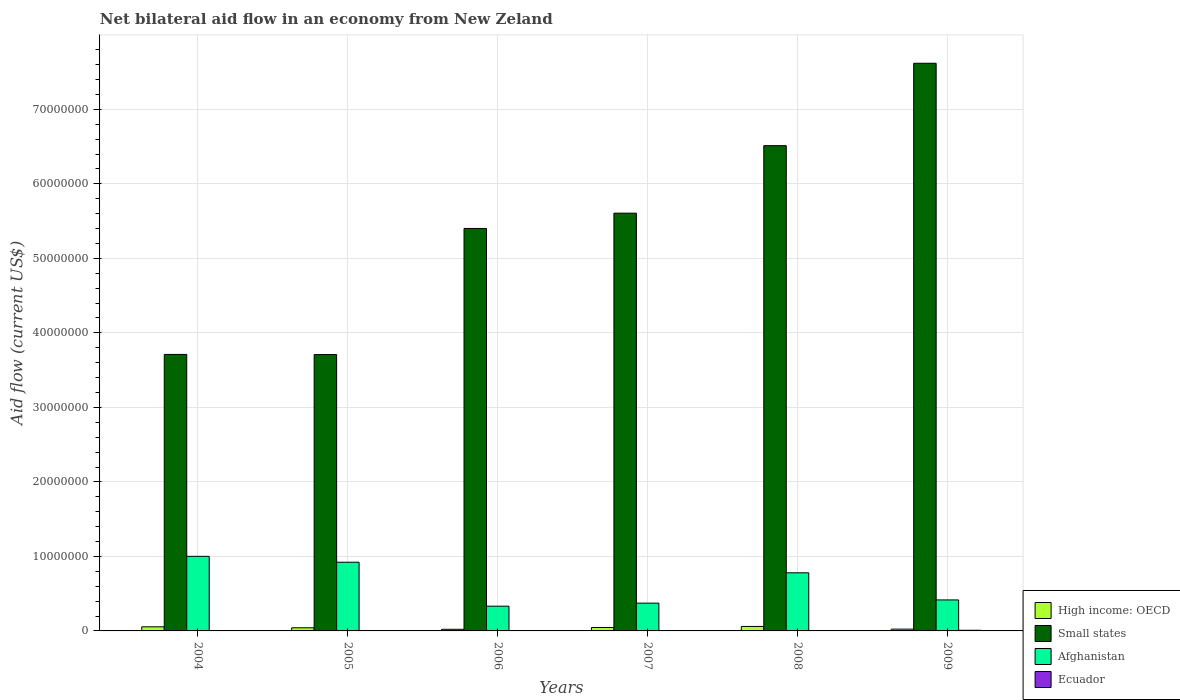How many different coloured bars are there?
Your response must be concise. 4. Are the number of bars per tick equal to the number of legend labels?
Provide a succinct answer. Yes. In how many cases, is the number of bars for a given year not equal to the number of legend labels?
Make the answer very short. 0. What is the net bilateral aid flow in Small states in 2005?
Give a very brief answer. 3.71e+07. Across all years, what is the maximum net bilateral aid flow in Ecuador?
Provide a short and direct response. 9.00e+04. In which year was the net bilateral aid flow in Afghanistan maximum?
Provide a succinct answer. 2004. What is the difference between the net bilateral aid flow in Afghanistan in 2006 and that in 2007?
Offer a very short reply. -4.10e+05. What is the average net bilateral aid flow in Ecuador per year?
Your answer should be very brief. 4.17e+04. In the year 2006, what is the difference between the net bilateral aid flow in High income: OECD and net bilateral aid flow in Small states?
Offer a terse response. -5.38e+07. What is the ratio of the net bilateral aid flow in Afghanistan in 2005 to that in 2007?
Your answer should be compact. 2.47. What is the difference between the highest and the lowest net bilateral aid flow in Afghanistan?
Your response must be concise. 6.69e+06. In how many years, is the net bilateral aid flow in Small states greater than the average net bilateral aid flow in Small states taken over all years?
Offer a terse response. 3. Is the sum of the net bilateral aid flow in Small states in 2006 and 2008 greater than the maximum net bilateral aid flow in High income: OECD across all years?
Provide a short and direct response. Yes. What does the 3rd bar from the left in 2008 represents?
Keep it short and to the point. Afghanistan. What does the 3rd bar from the right in 2008 represents?
Give a very brief answer. Small states. How many years are there in the graph?
Keep it short and to the point. 6. What is the difference between two consecutive major ticks on the Y-axis?
Your answer should be very brief. 1.00e+07. Does the graph contain any zero values?
Make the answer very short. No. Does the graph contain grids?
Give a very brief answer. Yes. How many legend labels are there?
Give a very brief answer. 4. How are the legend labels stacked?
Offer a terse response. Vertical. What is the title of the graph?
Offer a very short reply. Net bilateral aid flow in an economy from New Zeland. What is the label or title of the X-axis?
Provide a succinct answer. Years. What is the label or title of the Y-axis?
Ensure brevity in your answer.  Aid flow (current US$). What is the Aid flow (current US$) in Small states in 2004?
Your response must be concise. 3.71e+07. What is the Aid flow (current US$) in Afghanistan in 2004?
Give a very brief answer. 1.00e+07. What is the Aid flow (current US$) in Small states in 2005?
Offer a terse response. 3.71e+07. What is the Aid flow (current US$) in Afghanistan in 2005?
Your answer should be compact. 9.22e+06. What is the Aid flow (current US$) in Small states in 2006?
Give a very brief answer. 5.40e+07. What is the Aid flow (current US$) of Afghanistan in 2006?
Provide a short and direct response. 3.32e+06. What is the Aid flow (current US$) of High income: OECD in 2007?
Provide a short and direct response. 4.60e+05. What is the Aid flow (current US$) in Small states in 2007?
Offer a terse response. 5.61e+07. What is the Aid flow (current US$) in Afghanistan in 2007?
Provide a succinct answer. 3.73e+06. What is the Aid flow (current US$) in Ecuador in 2007?
Give a very brief answer. 2.00e+04. What is the Aid flow (current US$) in Small states in 2008?
Ensure brevity in your answer.  6.51e+07. What is the Aid flow (current US$) in Afghanistan in 2008?
Give a very brief answer. 7.80e+06. What is the Aid flow (current US$) of High income: OECD in 2009?
Give a very brief answer. 2.40e+05. What is the Aid flow (current US$) of Small states in 2009?
Ensure brevity in your answer.  7.62e+07. What is the Aid flow (current US$) of Afghanistan in 2009?
Your response must be concise. 4.16e+06. What is the Aid flow (current US$) of Ecuador in 2009?
Your answer should be compact. 9.00e+04. Across all years, what is the maximum Aid flow (current US$) of High income: OECD?
Make the answer very short. 6.00e+05. Across all years, what is the maximum Aid flow (current US$) of Small states?
Offer a very short reply. 7.62e+07. Across all years, what is the maximum Aid flow (current US$) in Afghanistan?
Ensure brevity in your answer.  1.00e+07. Across all years, what is the minimum Aid flow (current US$) in High income: OECD?
Provide a succinct answer. 2.20e+05. Across all years, what is the minimum Aid flow (current US$) in Small states?
Offer a very short reply. 3.71e+07. Across all years, what is the minimum Aid flow (current US$) in Afghanistan?
Ensure brevity in your answer.  3.32e+06. What is the total Aid flow (current US$) in High income: OECD in the graph?
Make the answer very short. 2.49e+06. What is the total Aid flow (current US$) in Small states in the graph?
Your answer should be very brief. 3.26e+08. What is the total Aid flow (current US$) of Afghanistan in the graph?
Keep it short and to the point. 3.82e+07. What is the total Aid flow (current US$) in Ecuador in the graph?
Offer a very short reply. 2.50e+05. What is the difference between the Aid flow (current US$) in High income: OECD in 2004 and that in 2005?
Make the answer very short. 1.30e+05. What is the difference between the Aid flow (current US$) of Small states in 2004 and that in 2005?
Offer a terse response. 2.00e+04. What is the difference between the Aid flow (current US$) of Afghanistan in 2004 and that in 2005?
Provide a succinct answer. 7.90e+05. What is the difference between the Aid flow (current US$) in Small states in 2004 and that in 2006?
Your response must be concise. -1.69e+07. What is the difference between the Aid flow (current US$) of Afghanistan in 2004 and that in 2006?
Keep it short and to the point. 6.69e+06. What is the difference between the Aid flow (current US$) of High income: OECD in 2004 and that in 2007?
Your response must be concise. 9.00e+04. What is the difference between the Aid flow (current US$) in Small states in 2004 and that in 2007?
Ensure brevity in your answer.  -1.90e+07. What is the difference between the Aid flow (current US$) in Afghanistan in 2004 and that in 2007?
Your answer should be compact. 6.28e+06. What is the difference between the Aid flow (current US$) in High income: OECD in 2004 and that in 2008?
Offer a terse response. -5.00e+04. What is the difference between the Aid flow (current US$) of Small states in 2004 and that in 2008?
Ensure brevity in your answer.  -2.80e+07. What is the difference between the Aid flow (current US$) in Afghanistan in 2004 and that in 2008?
Make the answer very short. 2.21e+06. What is the difference between the Aid flow (current US$) of Ecuador in 2004 and that in 2008?
Offer a terse response. -10000. What is the difference between the Aid flow (current US$) of High income: OECD in 2004 and that in 2009?
Your answer should be very brief. 3.10e+05. What is the difference between the Aid flow (current US$) of Small states in 2004 and that in 2009?
Offer a terse response. -3.91e+07. What is the difference between the Aid flow (current US$) in Afghanistan in 2004 and that in 2009?
Provide a short and direct response. 5.85e+06. What is the difference between the Aid flow (current US$) of High income: OECD in 2005 and that in 2006?
Make the answer very short. 2.00e+05. What is the difference between the Aid flow (current US$) of Small states in 2005 and that in 2006?
Keep it short and to the point. -1.69e+07. What is the difference between the Aid flow (current US$) in Afghanistan in 2005 and that in 2006?
Your answer should be very brief. 5.90e+06. What is the difference between the Aid flow (current US$) of Ecuador in 2005 and that in 2006?
Provide a succinct answer. -10000. What is the difference between the Aid flow (current US$) in High income: OECD in 2005 and that in 2007?
Your response must be concise. -4.00e+04. What is the difference between the Aid flow (current US$) in Small states in 2005 and that in 2007?
Ensure brevity in your answer.  -1.90e+07. What is the difference between the Aid flow (current US$) in Afghanistan in 2005 and that in 2007?
Offer a very short reply. 5.49e+06. What is the difference between the Aid flow (current US$) of Ecuador in 2005 and that in 2007?
Offer a terse response. 10000. What is the difference between the Aid flow (current US$) in Small states in 2005 and that in 2008?
Your response must be concise. -2.80e+07. What is the difference between the Aid flow (current US$) of Afghanistan in 2005 and that in 2008?
Provide a short and direct response. 1.42e+06. What is the difference between the Aid flow (current US$) of Ecuador in 2005 and that in 2008?
Provide a succinct answer. -10000. What is the difference between the Aid flow (current US$) in High income: OECD in 2005 and that in 2009?
Your response must be concise. 1.80e+05. What is the difference between the Aid flow (current US$) of Small states in 2005 and that in 2009?
Keep it short and to the point. -3.91e+07. What is the difference between the Aid flow (current US$) of Afghanistan in 2005 and that in 2009?
Ensure brevity in your answer.  5.06e+06. What is the difference between the Aid flow (current US$) in Small states in 2006 and that in 2007?
Make the answer very short. -2.05e+06. What is the difference between the Aid flow (current US$) in Afghanistan in 2006 and that in 2007?
Provide a short and direct response. -4.10e+05. What is the difference between the Aid flow (current US$) of High income: OECD in 2006 and that in 2008?
Give a very brief answer. -3.80e+05. What is the difference between the Aid flow (current US$) of Small states in 2006 and that in 2008?
Ensure brevity in your answer.  -1.11e+07. What is the difference between the Aid flow (current US$) of Afghanistan in 2006 and that in 2008?
Keep it short and to the point. -4.48e+06. What is the difference between the Aid flow (current US$) of Small states in 2006 and that in 2009?
Ensure brevity in your answer.  -2.22e+07. What is the difference between the Aid flow (current US$) in Afghanistan in 2006 and that in 2009?
Your response must be concise. -8.40e+05. What is the difference between the Aid flow (current US$) of Ecuador in 2006 and that in 2009?
Offer a very short reply. -5.00e+04. What is the difference between the Aid flow (current US$) in High income: OECD in 2007 and that in 2008?
Provide a succinct answer. -1.40e+05. What is the difference between the Aid flow (current US$) of Small states in 2007 and that in 2008?
Make the answer very short. -9.06e+06. What is the difference between the Aid flow (current US$) in Afghanistan in 2007 and that in 2008?
Offer a very short reply. -4.07e+06. What is the difference between the Aid flow (current US$) of Ecuador in 2007 and that in 2008?
Provide a short and direct response. -2.00e+04. What is the difference between the Aid flow (current US$) of Small states in 2007 and that in 2009?
Give a very brief answer. -2.01e+07. What is the difference between the Aid flow (current US$) in Afghanistan in 2007 and that in 2009?
Your response must be concise. -4.30e+05. What is the difference between the Aid flow (current US$) in Ecuador in 2007 and that in 2009?
Ensure brevity in your answer.  -7.00e+04. What is the difference between the Aid flow (current US$) in High income: OECD in 2008 and that in 2009?
Offer a very short reply. 3.60e+05. What is the difference between the Aid flow (current US$) of Small states in 2008 and that in 2009?
Your response must be concise. -1.11e+07. What is the difference between the Aid flow (current US$) in Afghanistan in 2008 and that in 2009?
Your answer should be compact. 3.64e+06. What is the difference between the Aid flow (current US$) in High income: OECD in 2004 and the Aid flow (current US$) in Small states in 2005?
Your response must be concise. -3.65e+07. What is the difference between the Aid flow (current US$) of High income: OECD in 2004 and the Aid flow (current US$) of Afghanistan in 2005?
Offer a very short reply. -8.67e+06. What is the difference between the Aid flow (current US$) of High income: OECD in 2004 and the Aid flow (current US$) of Ecuador in 2005?
Offer a terse response. 5.20e+05. What is the difference between the Aid flow (current US$) of Small states in 2004 and the Aid flow (current US$) of Afghanistan in 2005?
Offer a very short reply. 2.79e+07. What is the difference between the Aid flow (current US$) of Small states in 2004 and the Aid flow (current US$) of Ecuador in 2005?
Ensure brevity in your answer.  3.71e+07. What is the difference between the Aid flow (current US$) in Afghanistan in 2004 and the Aid flow (current US$) in Ecuador in 2005?
Your answer should be compact. 9.98e+06. What is the difference between the Aid flow (current US$) in High income: OECD in 2004 and the Aid flow (current US$) in Small states in 2006?
Keep it short and to the point. -5.35e+07. What is the difference between the Aid flow (current US$) of High income: OECD in 2004 and the Aid flow (current US$) of Afghanistan in 2006?
Your answer should be compact. -2.77e+06. What is the difference between the Aid flow (current US$) in High income: OECD in 2004 and the Aid flow (current US$) in Ecuador in 2006?
Make the answer very short. 5.10e+05. What is the difference between the Aid flow (current US$) of Small states in 2004 and the Aid flow (current US$) of Afghanistan in 2006?
Keep it short and to the point. 3.38e+07. What is the difference between the Aid flow (current US$) of Small states in 2004 and the Aid flow (current US$) of Ecuador in 2006?
Give a very brief answer. 3.71e+07. What is the difference between the Aid flow (current US$) of Afghanistan in 2004 and the Aid flow (current US$) of Ecuador in 2006?
Offer a very short reply. 9.97e+06. What is the difference between the Aid flow (current US$) of High income: OECD in 2004 and the Aid flow (current US$) of Small states in 2007?
Your response must be concise. -5.55e+07. What is the difference between the Aid flow (current US$) in High income: OECD in 2004 and the Aid flow (current US$) in Afghanistan in 2007?
Offer a very short reply. -3.18e+06. What is the difference between the Aid flow (current US$) in High income: OECD in 2004 and the Aid flow (current US$) in Ecuador in 2007?
Ensure brevity in your answer.  5.30e+05. What is the difference between the Aid flow (current US$) in Small states in 2004 and the Aid flow (current US$) in Afghanistan in 2007?
Your response must be concise. 3.34e+07. What is the difference between the Aid flow (current US$) of Small states in 2004 and the Aid flow (current US$) of Ecuador in 2007?
Give a very brief answer. 3.71e+07. What is the difference between the Aid flow (current US$) in Afghanistan in 2004 and the Aid flow (current US$) in Ecuador in 2007?
Keep it short and to the point. 9.99e+06. What is the difference between the Aid flow (current US$) of High income: OECD in 2004 and the Aid flow (current US$) of Small states in 2008?
Provide a succinct answer. -6.46e+07. What is the difference between the Aid flow (current US$) in High income: OECD in 2004 and the Aid flow (current US$) in Afghanistan in 2008?
Offer a very short reply. -7.25e+06. What is the difference between the Aid flow (current US$) of High income: OECD in 2004 and the Aid flow (current US$) of Ecuador in 2008?
Provide a succinct answer. 5.10e+05. What is the difference between the Aid flow (current US$) of Small states in 2004 and the Aid flow (current US$) of Afghanistan in 2008?
Your answer should be compact. 2.93e+07. What is the difference between the Aid flow (current US$) in Small states in 2004 and the Aid flow (current US$) in Ecuador in 2008?
Give a very brief answer. 3.71e+07. What is the difference between the Aid flow (current US$) of Afghanistan in 2004 and the Aid flow (current US$) of Ecuador in 2008?
Give a very brief answer. 9.97e+06. What is the difference between the Aid flow (current US$) in High income: OECD in 2004 and the Aid flow (current US$) in Small states in 2009?
Provide a short and direct response. -7.56e+07. What is the difference between the Aid flow (current US$) of High income: OECD in 2004 and the Aid flow (current US$) of Afghanistan in 2009?
Your response must be concise. -3.61e+06. What is the difference between the Aid flow (current US$) in Small states in 2004 and the Aid flow (current US$) in Afghanistan in 2009?
Offer a terse response. 3.30e+07. What is the difference between the Aid flow (current US$) of Small states in 2004 and the Aid flow (current US$) of Ecuador in 2009?
Provide a short and direct response. 3.70e+07. What is the difference between the Aid flow (current US$) of Afghanistan in 2004 and the Aid flow (current US$) of Ecuador in 2009?
Ensure brevity in your answer.  9.92e+06. What is the difference between the Aid flow (current US$) of High income: OECD in 2005 and the Aid flow (current US$) of Small states in 2006?
Your response must be concise. -5.36e+07. What is the difference between the Aid flow (current US$) in High income: OECD in 2005 and the Aid flow (current US$) in Afghanistan in 2006?
Offer a terse response. -2.90e+06. What is the difference between the Aid flow (current US$) of Small states in 2005 and the Aid flow (current US$) of Afghanistan in 2006?
Keep it short and to the point. 3.38e+07. What is the difference between the Aid flow (current US$) of Small states in 2005 and the Aid flow (current US$) of Ecuador in 2006?
Offer a very short reply. 3.70e+07. What is the difference between the Aid flow (current US$) in Afghanistan in 2005 and the Aid flow (current US$) in Ecuador in 2006?
Offer a terse response. 9.18e+06. What is the difference between the Aid flow (current US$) of High income: OECD in 2005 and the Aid flow (current US$) of Small states in 2007?
Make the answer very short. -5.56e+07. What is the difference between the Aid flow (current US$) of High income: OECD in 2005 and the Aid flow (current US$) of Afghanistan in 2007?
Provide a succinct answer. -3.31e+06. What is the difference between the Aid flow (current US$) in Small states in 2005 and the Aid flow (current US$) in Afghanistan in 2007?
Make the answer very short. 3.34e+07. What is the difference between the Aid flow (current US$) in Small states in 2005 and the Aid flow (current US$) in Ecuador in 2007?
Give a very brief answer. 3.71e+07. What is the difference between the Aid flow (current US$) of Afghanistan in 2005 and the Aid flow (current US$) of Ecuador in 2007?
Keep it short and to the point. 9.20e+06. What is the difference between the Aid flow (current US$) of High income: OECD in 2005 and the Aid flow (current US$) of Small states in 2008?
Your answer should be compact. -6.47e+07. What is the difference between the Aid flow (current US$) of High income: OECD in 2005 and the Aid flow (current US$) of Afghanistan in 2008?
Provide a short and direct response. -7.38e+06. What is the difference between the Aid flow (current US$) of High income: OECD in 2005 and the Aid flow (current US$) of Ecuador in 2008?
Your response must be concise. 3.80e+05. What is the difference between the Aid flow (current US$) in Small states in 2005 and the Aid flow (current US$) in Afghanistan in 2008?
Ensure brevity in your answer.  2.93e+07. What is the difference between the Aid flow (current US$) of Small states in 2005 and the Aid flow (current US$) of Ecuador in 2008?
Give a very brief answer. 3.70e+07. What is the difference between the Aid flow (current US$) in Afghanistan in 2005 and the Aid flow (current US$) in Ecuador in 2008?
Provide a succinct answer. 9.18e+06. What is the difference between the Aid flow (current US$) in High income: OECD in 2005 and the Aid flow (current US$) in Small states in 2009?
Give a very brief answer. -7.58e+07. What is the difference between the Aid flow (current US$) in High income: OECD in 2005 and the Aid flow (current US$) in Afghanistan in 2009?
Your response must be concise. -3.74e+06. What is the difference between the Aid flow (current US$) of High income: OECD in 2005 and the Aid flow (current US$) of Ecuador in 2009?
Offer a terse response. 3.30e+05. What is the difference between the Aid flow (current US$) in Small states in 2005 and the Aid flow (current US$) in Afghanistan in 2009?
Ensure brevity in your answer.  3.29e+07. What is the difference between the Aid flow (current US$) in Small states in 2005 and the Aid flow (current US$) in Ecuador in 2009?
Your answer should be compact. 3.70e+07. What is the difference between the Aid flow (current US$) of Afghanistan in 2005 and the Aid flow (current US$) of Ecuador in 2009?
Ensure brevity in your answer.  9.13e+06. What is the difference between the Aid flow (current US$) in High income: OECD in 2006 and the Aid flow (current US$) in Small states in 2007?
Offer a terse response. -5.58e+07. What is the difference between the Aid flow (current US$) in High income: OECD in 2006 and the Aid flow (current US$) in Afghanistan in 2007?
Your answer should be compact. -3.51e+06. What is the difference between the Aid flow (current US$) in Small states in 2006 and the Aid flow (current US$) in Afghanistan in 2007?
Keep it short and to the point. 5.03e+07. What is the difference between the Aid flow (current US$) in Small states in 2006 and the Aid flow (current US$) in Ecuador in 2007?
Keep it short and to the point. 5.40e+07. What is the difference between the Aid flow (current US$) in Afghanistan in 2006 and the Aid flow (current US$) in Ecuador in 2007?
Provide a short and direct response. 3.30e+06. What is the difference between the Aid flow (current US$) of High income: OECD in 2006 and the Aid flow (current US$) of Small states in 2008?
Provide a short and direct response. -6.49e+07. What is the difference between the Aid flow (current US$) of High income: OECD in 2006 and the Aid flow (current US$) of Afghanistan in 2008?
Your answer should be compact. -7.58e+06. What is the difference between the Aid flow (current US$) in High income: OECD in 2006 and the Aid flow (current US$) in Ecuador in 2008?
Offer a very short reply. 1.80e+05. What is the difference between the Aid flow (current US$) in Small states in 2006 and the Aid flow (current US$) in Afghanistan in 2008?
Offer a terse response. 4.62e+07. What is the difference between the Aid flow (current US$) of Small states in 2006 and the Aid flow (current US$) of Ecuador in 2008?
Your answer should be compact. 5.40e+07. What is the difference between the Aid flow (current US$) in Afghanistan in 2006 and the Aid flow (current US$) in Ecuador in 2008?
Offer a very short reply. 3.28e+06. What is the difference between the Aid flow (current US$) in High income: OECD in 2006 and the Aid flow (current US$) in Small states in 2009?
Give a very brief answer. -7.60e+07. What is the difference between the Aid flow (current US$) in High income: OECD in 2006 and the Aid flow (current US$) in Afghanistan in 2009?
Your response must be concise. -3.94e+06. What is the difference between the Aid flow (current US$) of Small states in 2006 and the Aid flow (current US$) of Afghanistan in 2009?
Your answer should be very brief. 4.99e+07. What is the difference between the Aid flow (current US$) of Small states in 2006 and the Aid flow (current US$) of Ecuador in 2009?
Provide a short and direct response. 5.39e+07. What is the difference between the Aid flow (current US$) in Afghanistan in 2006 and the Aid flow (current US$) in Ecuador in 2009?
Provide a short and direct response. 3.23e+06. What is the difference between the Aid flow (current US$) in High income: OECD in 2007 and the Aid flow (current US$) in Small states in 2008?
Offer a terse response. -6.47e+07. What is the difference between the Aid flow (current US$) in High income: OECD in 2007 and the Aid flow (current US$) in Afghanistan in 2008?
Your answer should be very brief. -7.34e+06. What is the difference between the Aid flow (current US$) of Small states in 2007 and the Aid flow (current US$) of Afghanistan in 2008?
Provide a short and direct response. 4.83e+07. What is the difference between the Aid flow (current US$) of Small states in 2007 and the Aid flow (current US$) of Ecuador in 2008?
Offer a terse response. 5.60e+07. What is the difference between the Aid flow (current US$) in Afghanistan in 2007 and the Aid flow (current US$) in Ecuador in 2008?
Your answer should be very brief. 3.69e+06. What is the difference between the Aid flow (current US$) of High income: OECD in 2007 and the Aid flow (current US$) of Small states in 2009?
Your response must be concise. -7.57e+07. What is the difference between the Aid flow (current US$) of High income: OECD in 2007 and the Aid flow (current US$) of Afghanistan in 2009?
Your answer should be compact. -3.70e+06. What is the difference between the Aid flow (current US$) in High income: OECD in 2007 and the Aid flow (current US$) in Ecuador in 2009?
Offer a very short reply. 3.70e+05. What is the difference between the Aid flow (current US$) of Small states in 2007 and the Aid flow (current US$) of Afghanistan in 2009?
Give a very brief answer. 5.19e+07. What is the difference between the Aid flow (current US$) in Small states in 2007 and the Aid flow (current US$) in Ecuador in 2009?
Give a very brief answer. 5.60e+07. What is the difference between the Aid flow (current US$) in Afghanistan in 2007 and the Aid flow (current US$) in Ecuador in 2009?
Your answer should be very brief. 3.64e+06. What is the difference between the Aid flow (current US$) in High income: OECD in 2008 and the Aid flow (current US$) in Small states in 2009?
Ensure brevity in your answer.  -7.56e+07. What is the difference between the Aid flow (current US$) in High income: OECD in 2008 and the Aid flow (current US$) in Afghanistan in 2009?
Keep it short and to the point. -3.56e+06. What is the difference between the Aid flow (current US$) of High income: OECD in 2008 and the Aid flow (current US$) of Ecuador in 2009?
Offer a terse response. 5.10e+05. What is the difference between the Aid flow (current US$) in Small states in 2008 and the Aid flow (current US$) in Afghanistan in 2009?
Your answer should be very brief. 6.10e+07. What is the difference between the Aid flow (current US$) of Small states in 2008 and the Aid flow (current US$) of Ecuador in 2009?
Offer a terse response. 6.50e+07. What is the difference between the Aid flow (current US$) in Afghanistan in 2008 and the Aid flow (current US$) in Ecuador in 2009?
Offer a terse response. 7.71e+06. What is the average Aid flow (current US$) in High income: OECD per year?
Make the answer very short. 4.15e+05. What is the average Aid flow (current US$) of Small states per year?
Provide a short and direct response. 5.43e+07. What is the average Aid flow (current US$) in Afghanistan per year?
Offer a terse response. 6.37e+06. What is the average Aid flow (current US$) in Ecuador per year?
Provide a succinct answer. 4.17e+04. In the year 2004, what is the difference between the Aid flow (current US$) of High income: OECD and Aid flow (current US$) of Small states?
Your response must be concise. -3.66e+07. In the year 2004, what is the difference between the Aid flow (current US$) in High income: OECD and Aid flow (current US$) in Afghanistan?
Ensure brevity in your answer.  -9.46e+06. In the year 2004, what is the difference between the Aid flow (current US$) of High income: OECD and Aid flow (current US$) of Ecuador?
Offer a terse response. 5.20e+05. In the year 2004, what is the difference between the Aid flow (current US$) of Small states and Aid flow (current US$) of Afghanistan?
Provide a succinct answer. 2.71e+07. In the year 2004, what is the difference between the Aid flow (current US$) of Small states and Aid flow (current US$) of Ecuador?
Your response must be concise. 3.71e+07. In the year 2004, what is the difference between the Aid flow (current US$) of Afghanistan and Aid flow (current US$) of Ecuador?
Keep it short and to the point. 9.98e+06. In the year 2005, what is the difference between the Aid flow (current US$) of High income: OECD and Aid flow (current US$) of Small states?
Offer a very short reply. -3.67e+07. In the year 2005, what is the difference between the Aid flow (current US$) in High income: OECD and Aid flow (current US$) in Afghanistan?
Your answer should be compact. -8.80e+06. In the year 2005, what is the difference between the Aid flow (current US$) of High income: OECD and Aid flow (current US$) of Ecuador?
Offer a terse response. 3.90e+05. In the year 2005, what is the difference between the Aid flow (current US$) in Small states and Aid flow (current US$) in Afghanistan?
Your answer should be compact. 2.79e+07. In the year 2005, what is the difference between the Aid flow (current US$) in Small states and Aid flow (current US$) in Ecuador?
Your answer should be very brief. 3.71e+07. In the year 2005, what is the difference between the Aid flow (current US$) in Afghanistan and Aid flow (current US$) in Ecuador?
Your answer should be very brief. 9.19e+06. In the year 2006, what is the difference between the Aid flow (current US$) of High income: OECD and Aid flow (current US$) of Small states?
Your answer should be compact. -5.38e+07. In the year 2006, what is the difference between the Aid flow (current US$) in High income: OECD and Aid flow (current US$) in Afghanistan?
Give a very brief answer. -3.10e+06. In the year 2006, what is the difference between the Aid flow (current US$) of Small states and Aid flow (current US$) of Afghanistan?
Your response must be concise. 5.07e+07. In the year 2006, what is the difference between the Aid flow (current US$) of Small states and Aid flow (current US$) of Ecuador?
Offer a terse response. 5.40e+07. In the year 2006, what is the difference between the Aid flow (current US$) of Afghanistan and Aid flow (current US$) of Ecuador?
Your answer should be very brief. 3.28e+06. In the year 2007, what is the difference between the Aid flow (current US$) of High income: OECD and Aid flow (current US$) of Small states?
Your response must be concise. -5.56e+07. In the year 2007, what is the difference between the Aid flow (current US$) in High income: OECD and Aid flow (current US$) in Afghanistan?
Make the answer very short. -3.27e+06. In the year 2007, what is the difference between the Aid flow (current US$) in Small states and Aid flow (current US$) in Afghanistan?
Your answer should be very brief. 5.23e+07. In the year 2007, what is the difference between the Aid flow (current US$) of Small states and Aid flow (current US$) of Ecuador?
Give a very brief answer. 5.60e+07. In the year 2007, what is the difference between the Aid flow (current US$) in Afghanistan and Aid flow (current US$) in Ecuador?
Provide a succinct answer. 3.71e+06. In the year 2008, what is the difference between the Aid flow (current US$) in High income: OECD and Aid flow (current US$) in Small states?
Provide a short and direct response. -6.45e+07. In the year 2008, what is the difference between the Aid flow (current US$) in High income: OECD and Aid flow (current US$) in Afghanistan?
Your answer should be compact. -7.20e+06. In the year 2008, what is the difference between the Aid flow (current US$) of High income: OECD and Aid flow (current US$) of Ecuador?
Your answer should be compact. 5.60e+05. In the year 2008, what is the difference between the Aid flow (current US$) in Small states and Aid flow (current US$) in Afghanistan?
Offer a terse response. 5.73e+07. In the year 2008, what is the difference between the Aid flow (current US$) of Small states and Aid flow (current US$) of Ecuador?
Give a very brief answer. 6.51e+07. In the year 2008, what is the difference between the Aid flow (current US$) in Afghanistan and Aid flow (current US$) in Ecuador?
Offer a very short reply. 7.76e+06. In the year 2009, what is the difference between the Aid flow (current US$) of High income: OECD and Aid flow (current US$) of Small states?
Ensure brevity in your answer.  -7.60e+07. In the year 2009, what is the difference between the Aid flow (current US$) in High income: OECD and Aid flow (current US$) in Afghanistan?
Keep it short and to the point. -3.92e+06. In the year 2009, what is the difference between the Aid flow (current US$) in Small states and Aid flow (current US$) in Afghanistan?
Your response must be concise. 7.20e+07. In the year 2009, what is the difference between the Aid flow (current US$) in Small states and Aid flow (current US$) in Ecuador?
Offer a very short reply. 7.61e+07. In the year 2009, what is the difference between the Aid flow (current US$) of Afghanistan and Aid flow (current US$) of Ecuador?
Offer a terse response. 4.07e+06. What is the ratio of the Aid flow (current US$) of High income: OECD in 2004 to that in 2005?
Provide a succinct answer. 1.31. What is the ratio of the Aid flow (current US$) of Small states in 2004 to that in 2005?
Keep it short and to the point. 1. What is the ratio of the Aid flow (current US$) of Afghanistan in 2004 to that in 2005?
Your answer should be very brief. 1.09. What is the ratio of the Aid flow (current US$) in Small states in 2004 to that in 2006?
Give a very brief answer. 0.69. What is the ratio of the Aid flow (current US$) of Afghanistan in 2004 to that in 2006?
Give a very brief answer. 3.02. What is the ratio of the Aid flow (current US$) of Ecuador in 2004 to that in 2006?
Make the answer very short. 0.75. What is the ratio of the Aid flow (current US$) in High income: OECD in 2004 to that in 2007?
Your response must be concise. 1.2. What is the ratio of the Aid flow (current US$) of Small states in 2004 to that in 2007?
Make the answer very short. 0.66. What is the ratio of the Aid flow (current US$) of Afghanistan in 2004 to that in 2007?
Provide a succinct answer. 2.68. What is the ratio of the Aid flow (current US$) in Ecuador in 2004 to that in 2007?
Make the answer very short. 1.5. What is the ratio of the Aid flow (current US$) in High income: OECD in 2004 to that in 2008?
Provide a short and direct response. 0.92. What is the ratio of the Aid flow (current US$) of Small states in 2004 to that in 2008?
Ensure brevity in your answer.  0.57. What is the ratio of the Aid flow (current US$) in Afghanistan in 2004 to that in 2008?
Give a very brief answer. 1.28. What is the ratio of the Aid flow (current US$) in High income: OECD in 2004 to that in 2009?
Provide a short and direct response. 2.29. What is the ratio of the Aid flow (current US$) of Small states in 2004 to that in 2009?
Offer a very short reply. 0.49. What is the ratio of the Aid flow (current US$) of Afghanistan in 2004 to that in 2009?
Keep it short and to the point. 2.41. What is the ratio of the Aid flow (current US$) of Ecuador in 2004 to that in 2009?
Make the answer very short. 0.33. What is the ratio of the Aid flow (current US$) in High income: OECD in 2005 to that in 2006?
Your answer should be very brief. 1.91. What is the ratio of the Aid flow (current US$) of Small states in 2005 to that in 2006?
Offer a very short reply. 0.69. What is the ratio of the Aid flow (current US$) in Afghanistan in 2005 to that in 2006?
Offer a very short reply. 2.78. What is the ratio of the Aid flow (current US$) of Ecuador in 2005 to that in 2006?
Keep it short and to the point. 0.75. What is the ratio of the Aid flow (current US$) of Small states in 2005 to that in 2007?
Your answer should be very brief. 0.66. What is the ratio of the Aid flow (current US$) of Afghanistan in 2005 to that in 2007?
Ensure brevity in your answer.  2.47. What is the ratio of the Aid flow (current US$) in High income: OECD in 2005 to that in 2008?
Offer a terse response. 0.7. What is the ratio of the Aid flow (current US$) in Small states in 2005 to that in 2008?
Offer a very short reply. 0.57. What is the ratio of the Aid flow (current US$) in Afghanistan in 2005 to that in 2008?
Your answer should be compact. 1.18. What is the ratio of the Aid flow (current US$) in Small states in 2005 to that in 2009?
Provide a succinct answer. 0.49. What is the ratio of the Aid flow (current US$) in Afghanistan in 2005 to that in 2009?
Offer a very short reply. 2.22. What is the ratio of the Aid flow (current US$) in Ecuador in 2005 to that in 2009?
Give a very brief answer. 0.33. What is the ratio of the Aid flow (current US$) in High income: OECD in 2006 to that in 2007?
Provide a succinct answer. 0.48. What is the ratio of the Aid flow (current US$) in Small states in 2006 to that in 2007?
Provide a succinct answer. 0.96. What is the ratio of the Aid flow (current US$) in Afghanistan in 2006 to that in 2007?
Keep it short and to the point. 0.89. What is the ratio of the Aid flow (current US$) of Ecuador in 2006 to that in 2007?
Give a very brief answer. 2. What is the ratio of the Aid flow (current US$) in High income: OECD in 2006 to that in 2008?
Your answer should be very brief. 0.37. What is the ratio of the Aid flow (current US$) in Small states in 2006 to that in 2008?
Ensure brevity in your answer.  0.83. What is the ratio of the Aid flow (current US$) in Afghanistan in 2006 to that in 2008?
Offer a very short reply. 0.43. What is the ratio of the Aid flow (current US$) of High income: OECD in 2006 to that in 2009?
Give a very brief answer. 0.92. What is the ratio of the Aid flow (current US$) in Small states in 2006 to that in 2009?
Offer a very short reply. 0.71. What is the ratio of the Aid flow (current US$) in Afghanistan in 2006 to that in 2009?
Keep it short and to the point. 0.8. What is the ratio of the Aid flow (current US$) of Ecuador in 2006 to that in 2009?
Provide a succinct answer. 0.44. What is the ratio of the Aid flow (current US$) in High income: OECD in 2007 to that in 2008?
Keep it short and to the point. 0.77. What is the ratio of the Aid flow (current US$) in Small states in 2007 to that in 2008?
Keep it short and to the point. 0.86. What is the ratio of the Aid flow (current US$) of Afghanistan in 2007 to that in 2008?
Offer a very short reply. 0.48. What is the ratio of the Aid flow (current US$) of High income: OECD in 2007 to that in 2009?
Offer a terse response. 1.92. What is the ratio of the Aid flow (current US$) in Small states in 2007 to that in 2009?
Provide a succinct answer. 0.74. What is the ratio of the Aid flow (current US$) of Afghanistan in 2007 to that in 2009?
Offer a terse response. 0.9. What is the ratio of the Aid flow (current US$) in Ecuador in 2007 to that in 2009?
Keep it short and to the point. 0.22. What is the ratio of the Aid flow (current US$) in High income: OECD in 2008 to that in 2009?
Provide a short and direct response. 2.5. What is the ratio of the Aid flow (current US$) in Small states in 2008 to that in 2009?
Provide a succinct answer. 0.85. What is the ratio of the Aid flow (current US$) in Afghanistan in 2008 to that in 2009?
Offer a terse response. 1.88. What is the ratio of the Aid flow (current US$) of Ecuador in 2008 to that in 2009?
Offer a very short reply. 0.44. What is the difference between the highest and the second highest Aid flow (current US$) of Small states?
Offer a terse response. 1.11e+07. What is the difference between the highest and the second highest Aid flow (current US$) of Afghanistan?
Offer a very short reply. 7.90e+05. What is the difference between the highest and the second highest Aid flow (current US$) of Ecuador?
Provide a short and direct response. 5.00e+04. What is the difference between the highest and the lowest Aid flow (current US$) in Small states?
Give a very brief answer. 3.91e+07. What is the difference between the highest and the lowest Aid flow (current US$) of Afghanistan?
Ensure brevity in your answer.  6.69e+06. 